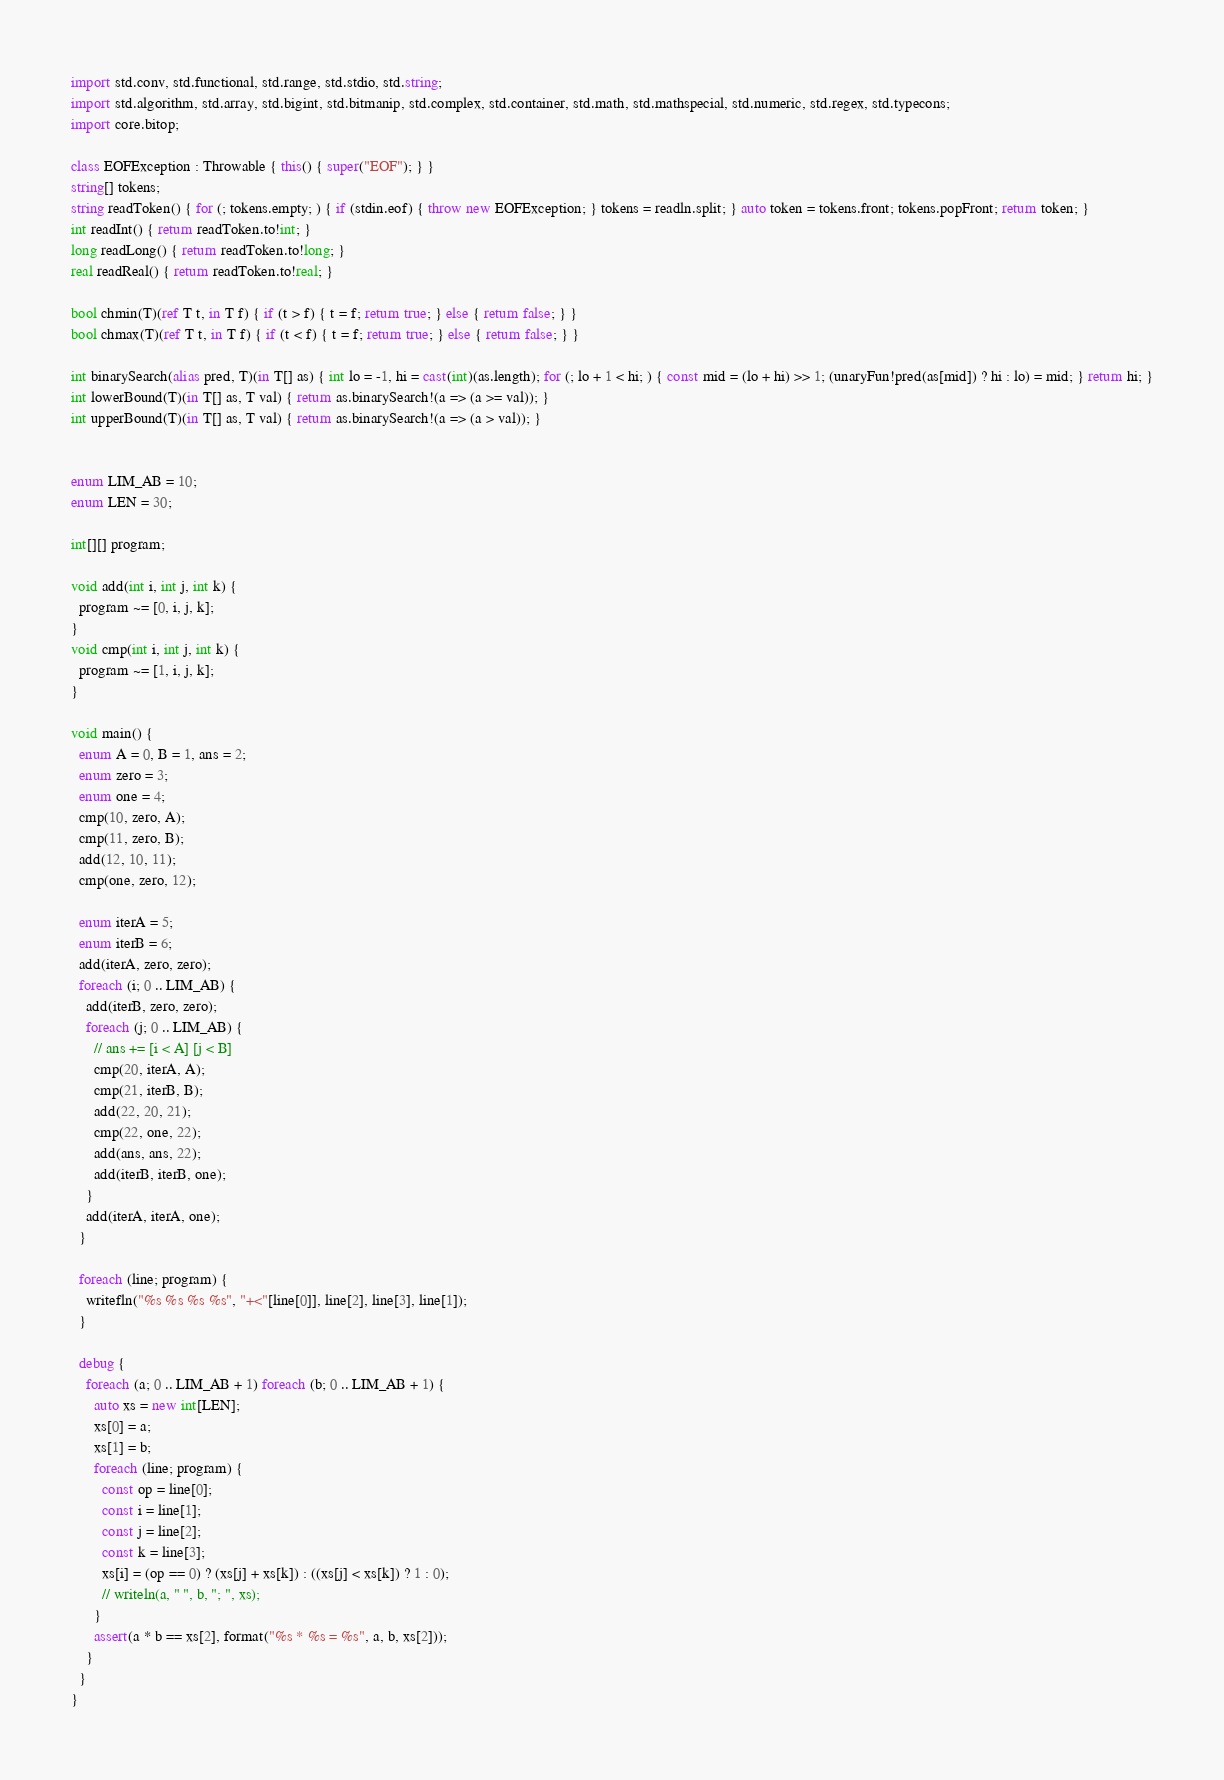Convert code to text. <code><loc_0><loc_0><loc_500><loc_500><_D_>import std.conv, std.functional, std.range, std.stdio, std.string;
import std.algorithm, std.array, std.bigint, std.bitmanip, std.complex, std.container, std.math, std.mathspecial, std.numeric, std.regex, std.typecons;
import core.bitop;

class EOFException : Throwable { this() { super("EOF"); } }
string[] tokens;
string readToken() { for (; tokens.empty; ) { if (stdin.eof) { throw new EOFException; } tokens = readln.split; } auto token = tokens.front; tokens.popFront; return token; }
int readInt() { return readToken.to!int; }
long readLong() { return readToken.to!long; }
real readReal() { return readToken.to!real; }

bool chmin(T)(ref T t, in T f) { if (t > f) { t = f; return true; } else { return false; } }
bool chmax(T)(ref T t, in T f) { if (t < f) { t = f; return true; } else { return false; } }

int binarySearch(alias pred, T)(in T[] as) { int lo = -1, hi = cast(int)(as.length); for (; lo + 1 < hi; ) { const mid = (lo + hi) >> 1; (unaryFun!pred(as[mid]) ? hi : lo) = mid; } return hi; }
int lowerBound(T)(in T[] as, T val) { return as.binarySearch!(a => (a >= val)); }
int upperBound(T)(in T[] as, T val) { return as.binarySearch!(a => (a > val)); }


enum LIM_AB = 10;
enum LEN = 30;

int[][] program;

void add(int i, int j, int k) {
  program ~= [0, i, j, k];
}
void cmp(int i, int j, int k) {
  program ~= [1, i, j, k];
}

void main() {
  enum A = 0, B = 1, ans = 2;
  enum zero = 3;
  enum one = 4;
  cmp(10, zero, A);
  cmp(11, zero, B);
  add(12, 10, 11);
  cmp(one, zero, 12);
  
  enum iterA = 5;
  enum iterB = 6;
  add(iterA, zero, zero);
  foreach (i; 0 .. LIM_AB) {
    add(iterB, zero, zero);
    foreach (j; 0 .. LIM_AB) {
      // ans += [i < A] [j < B]
      cmp(20, iterA, A);
      cmp(21, iterB, B);
      add(22, 20, 21);
      cmp(22, one, 22);
      add(ans, ans, 22);
      add(iterB, iterB, one);
    }
    add(iterA, iterA, one);
  }
  
  foreach (line; program) {
    writefln("%s %s %s %s", "+<"[line[0]], line[2], line[3], line[1]);
  }
  
  debug {
    foreach (a; 0 .. LIM_AB + 1) foreach (b; 0 .. LIM_AB + 1) {
      auto xs = new int[LEN];
      xs[0] = a;
      xs[1] = b;
      foreach (line; program) {
        const op = line[0];
        const i = line[1];
        const j = line[2];
        const k = line[3];
        xs[i] = (op == 0) ? (xs[j] + xs[k]) : ((xs[j] < xs[k]) ? 1 : 0);
        // writeln(a, " ", b, "; ", xs);
      }
      assert(a * b == xs[2], format("%s * %s = %s", a, b, xs[2]));
    }
  }
}
</code> 